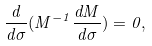<formula> <loc_0><loc_0><loc_500><loc_500>\frac { d } { d \sigma } ( M ^ { - 1 } \frac { d M } { d \sigma } ) = 0 ,</formula> 